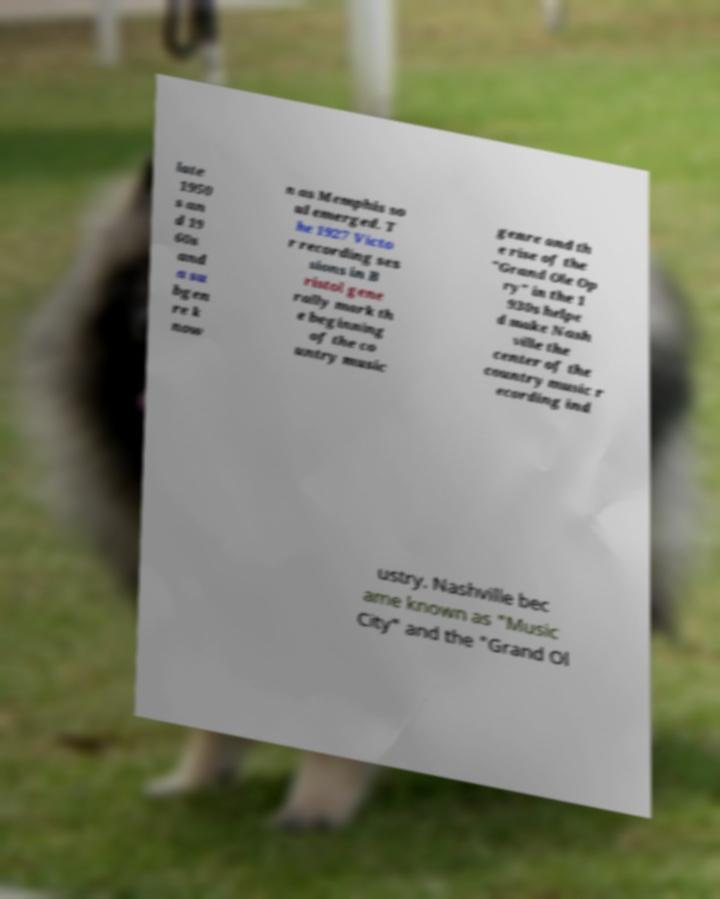What messages or text are displayed in this image? I need them in a readable, typed format. late 1950 s an d 19 60s and a su bgen re k now n as Memphis so ul emerged. T he 1927 Victo r recording ses sions in B ristol gene rally mark th e beginning of the co untry music genre and th e rise of the "Grand Ole Op ry" in the 1 930s helpe d make Nash ville the center of the country music r ecording ind ustry. Nashville bec ame known as "Music City" and the "Grand Ol 